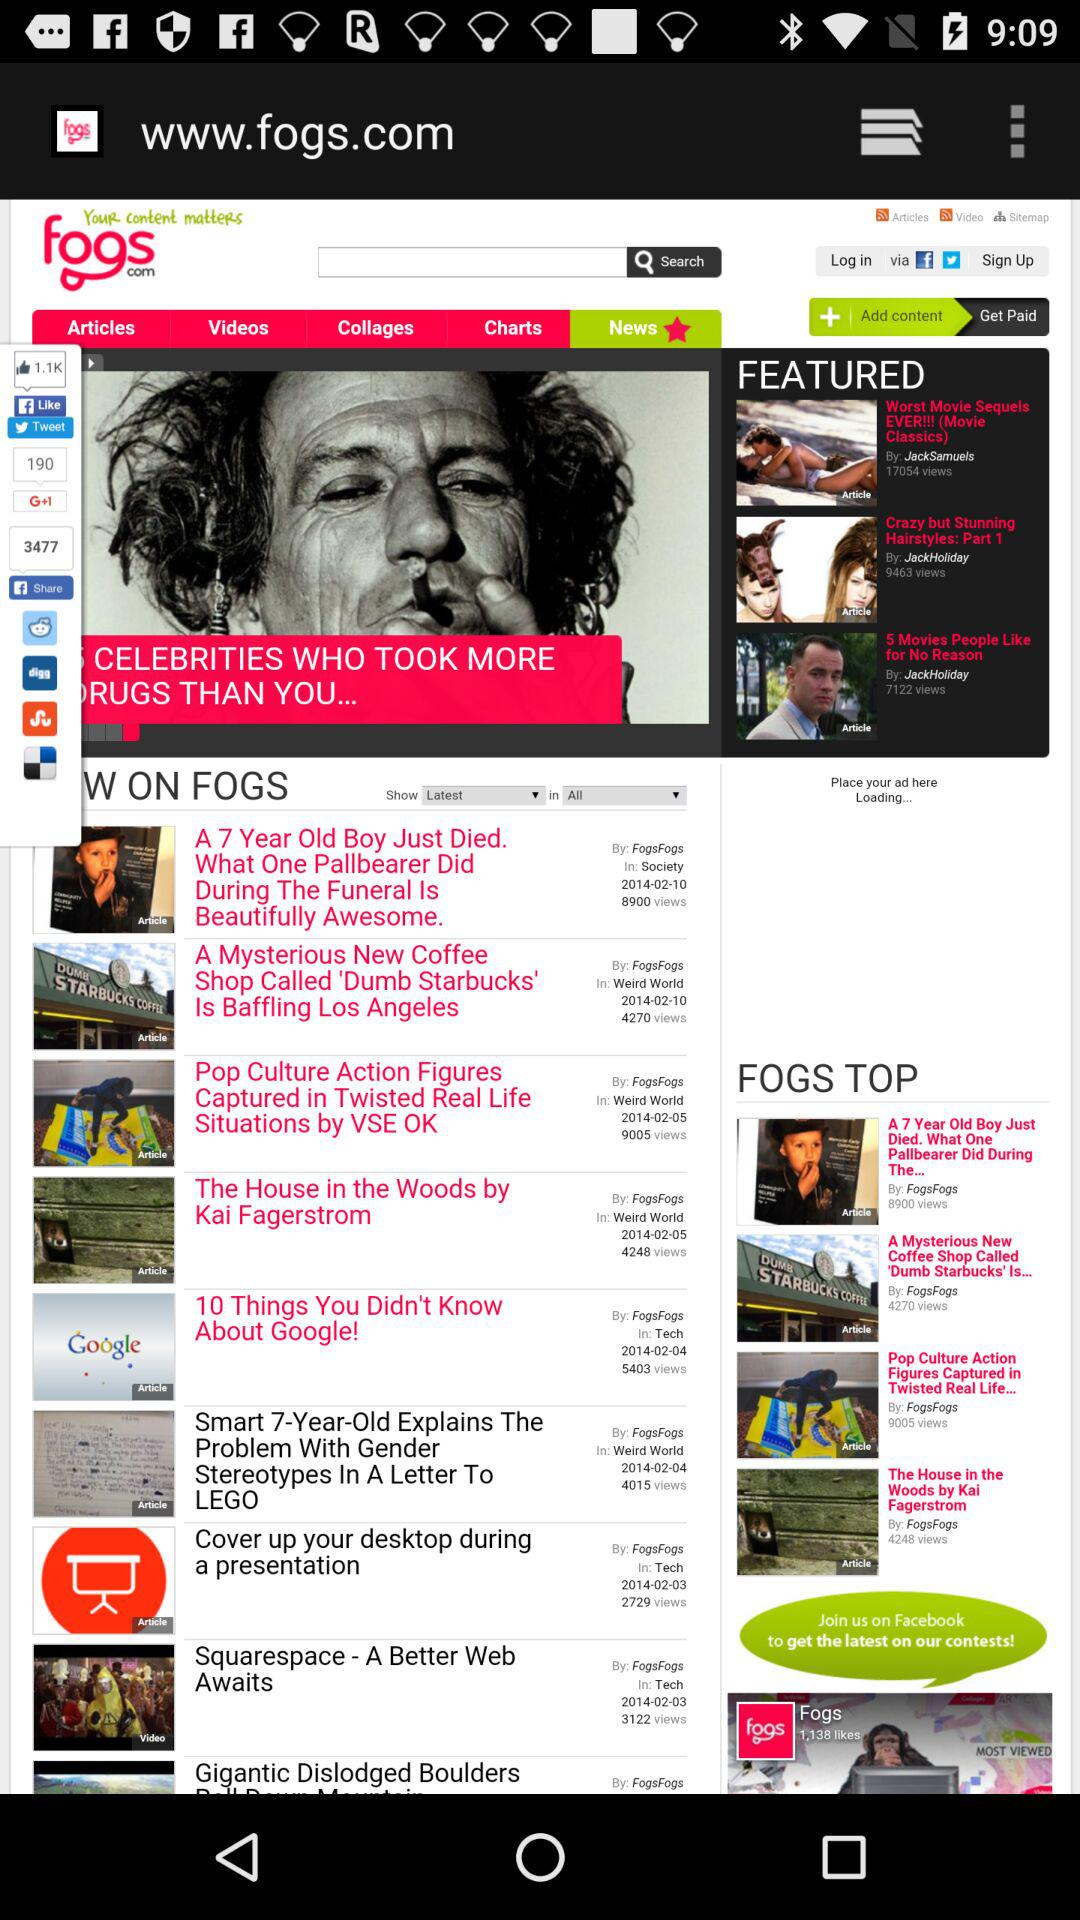What is the website's name? The website's name is "www.fogs.com". 